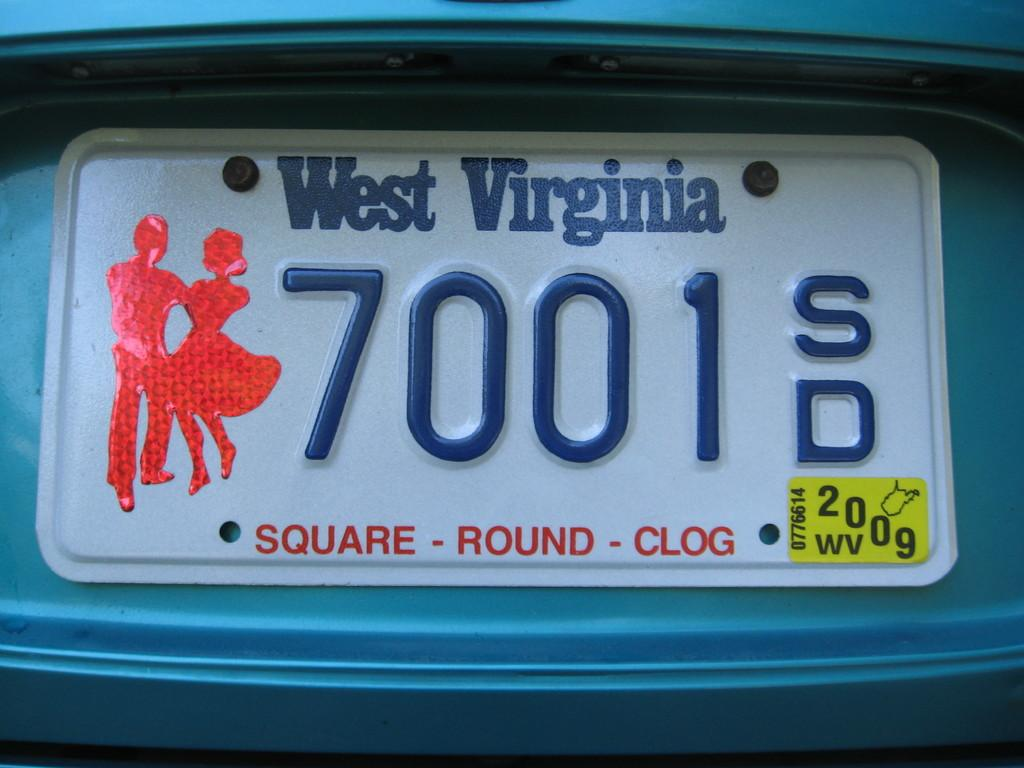What can be seen in the image related to a vehicle? There is a number plate of a vehicle in the image. What type of tray is being used to hold the property of the tramp in the image? There is no tray, property, or tramp present in the image; it only features a number plate of a vehicle. 